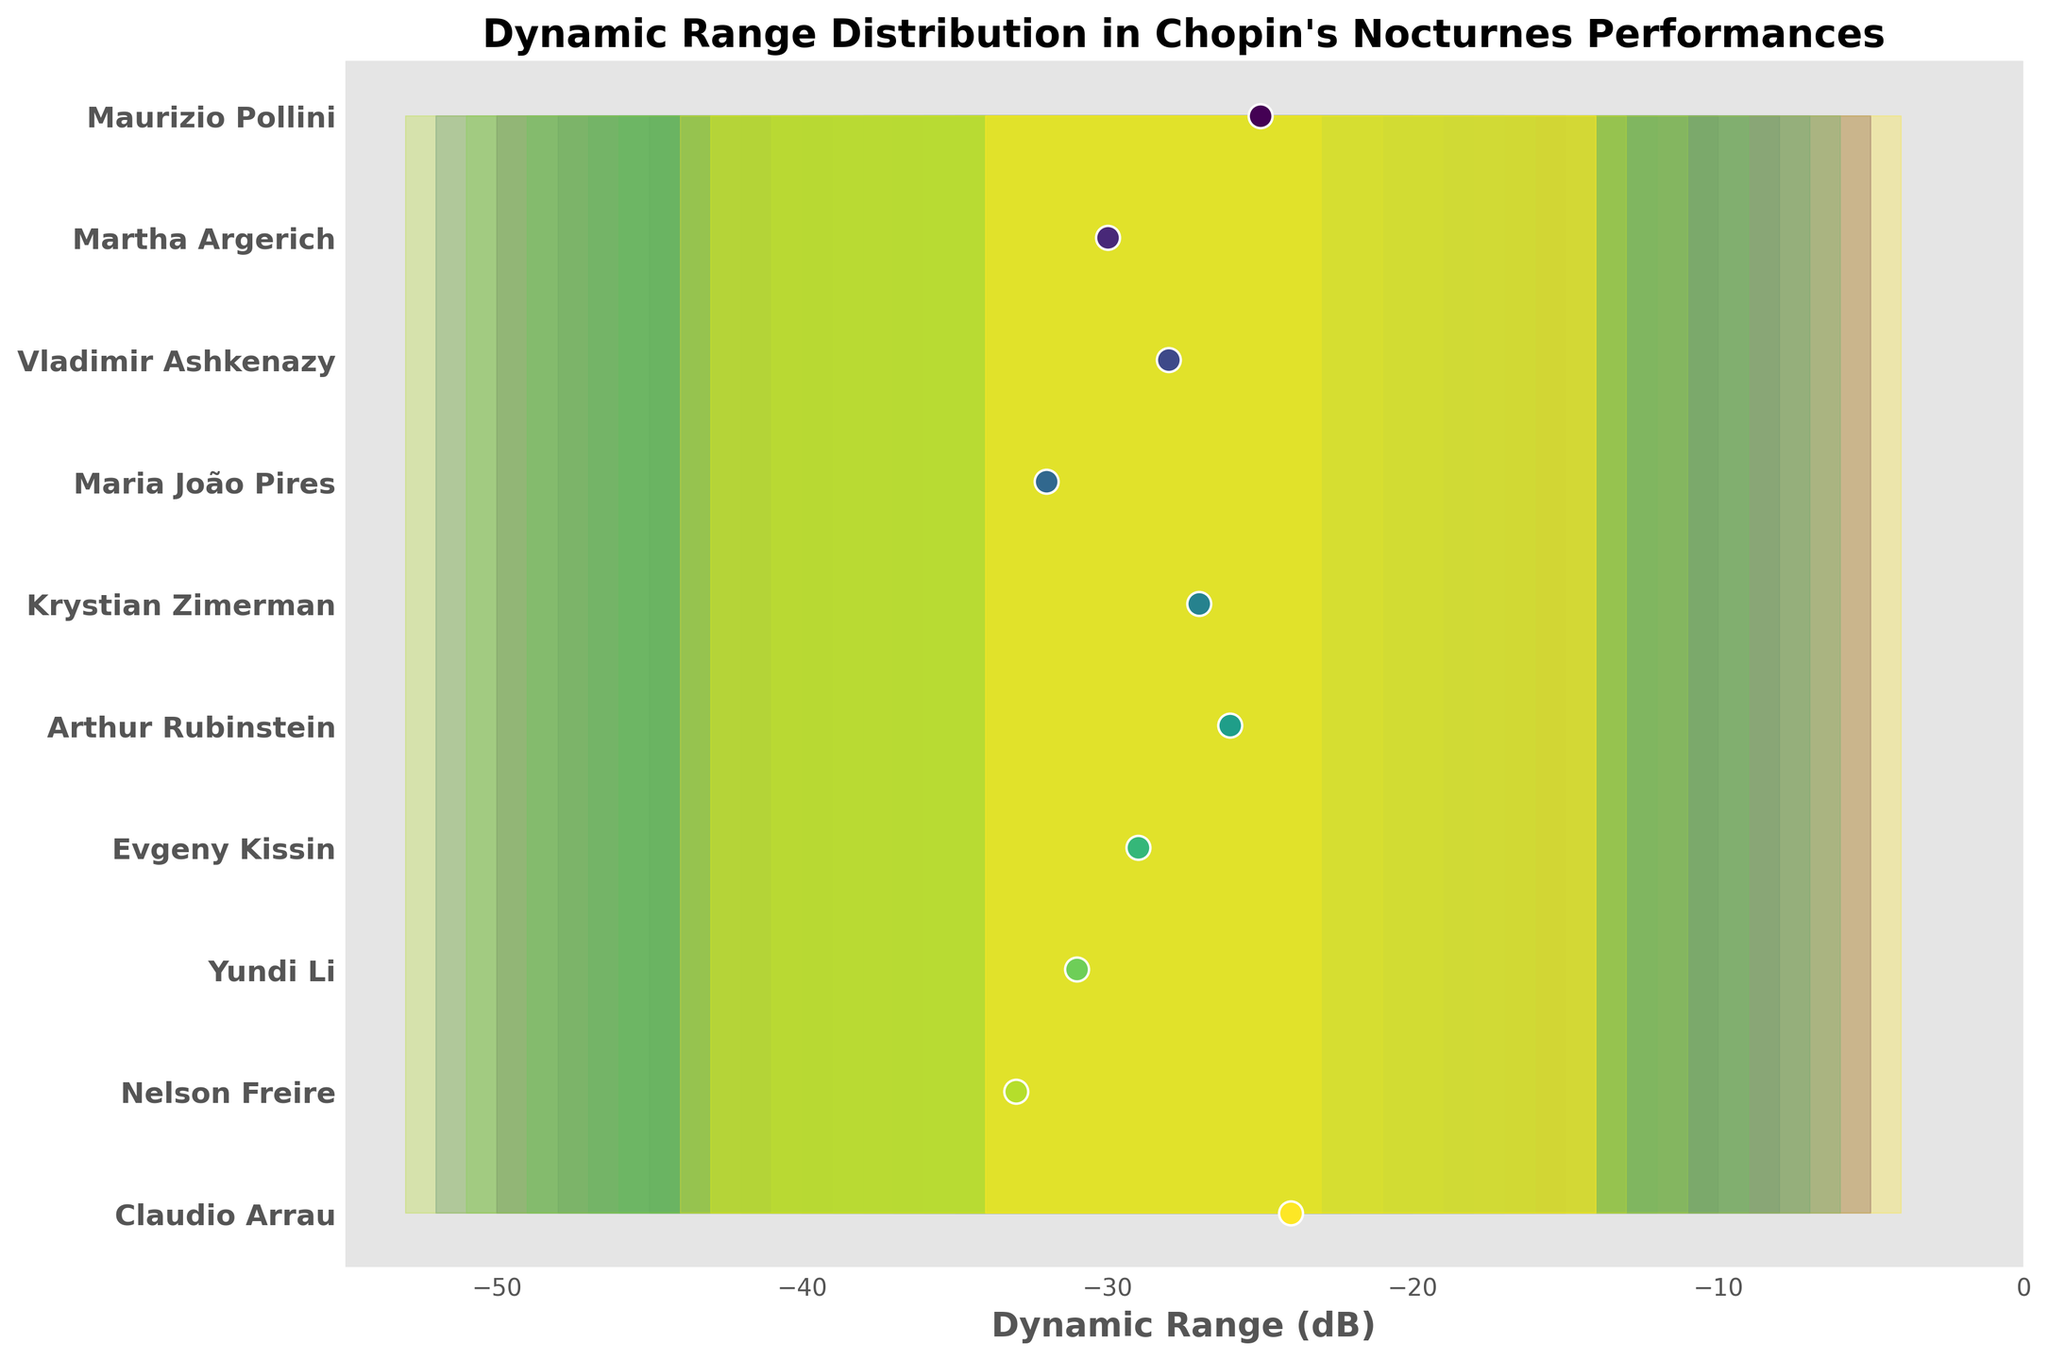What's the title of the figure? The title is usually placed at the top of the figure, and in this case, it is clearly written.
Answer: Dynamic Range Distribution in Chopin's Nocturnes Performances How many pianists are included in the figure? To find the number of pianists, count the number of labeled data points on the y-axis.
Answer: 10 Which pianist has the widest dynamic range based on the maximum and minimum dB values? The widest range is determined by subtracting the minimum dB value from the maximum dB value for each pianist and comparing the results. Nelson Freire has the widest range with (-13) - (-53) = 40 dB.
Answer: Nelson Freire Who has the smallest interquartile range (IQR) of dynamics? The IQR is the difference between the upper quartile and lower quartile dB. Calculate this for each pianist and find the smallest value. Claudio Arrau's IQR is (-14) - (-34) = 20 dB.
Answer: Claudio Arrau What is the median dynamic range of Arthur Rubinstein's performance? The median value is represented by a distinct marker, in this case, an 'o' marker. For Arthur Rubinstein, it is at -26 dB.
Answer: -26 dB Compare the overall dynamics of Martha Argerich and Maria João Pires. Who has a more compressed dynamic range? To compare, evaluate the overall range from the minimum to maximum dB for both pianists. Martha Argerich has a range from -50 to -10 dB (40 dB), and Maria João Pires has a range from -52 to -12 dB (40 dB). Both have the same dynamic range width of 40 dB.
Answer: Both have the same range Between Vladimir Ashkenazy and Krystian Zimerman, who has a higher median dynamic range? Compare the median dB values represented by the markers. Vladimir Ashkenazy has a median of -28 dB and Krystian Zimerman has a median of -27 dB.
Answer: Krystian Zimerman Which pianist has the highest minimum dB value? The highest minimum value can be observed by looking at the starting point of the filled area at the leftmost edge of the chart. Claudio Arrau has the highest minimum dB value at -44 dB.
Answer: Claudio Arrau What does the shaded area represent in the figure? The shaded areas represent the dynamic range distributions for each pianist. The lighter shaded area covers the full range from minimum to maximum values, while the darker shaded area represents the interquartile range (IQR).
Answer: Dynamic range distributions and IQRs If you were to listen to the quietest average interpretation, whose performance would you choose? The quietest average performance is indicated by the pianist with the lowest median dB value. Nelson Freire has the lowest median at -33 dB.
Answer: Nelson Freire 